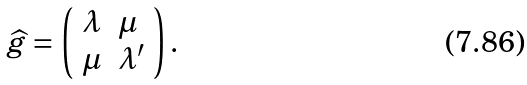<formula> <loc_0><loc_0><loc_500><loc_500>\widehat { g } = \left ( \begin{array} { l l } \lambda & \mu \\ \mu & \lambda ^ { \prime } \end{array} \right ) .</formula> 